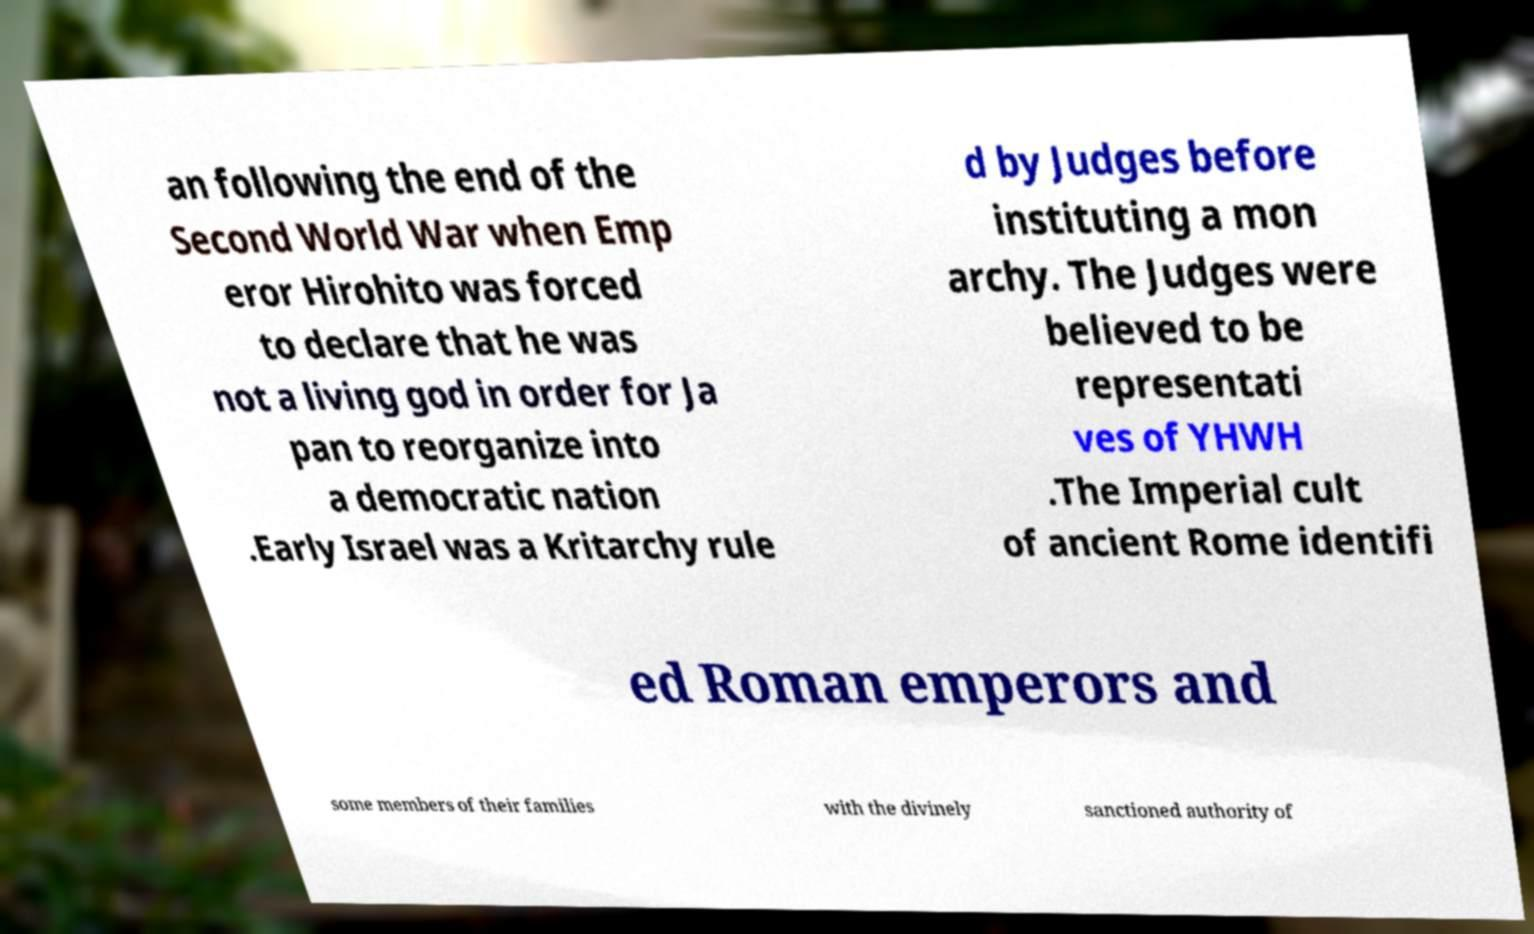I need the written content from this picture converted into text. Can you do that? an following the end of the Second World War when Emp eror Hirohito was forced to declare that he was not a living god in order for Ja pan to reorganize into a democratic nation .Early Israel was a Kritarchy rule d by Judges before instituting a mon archy. The Judges were believed to be representati ves of YHWH .The Imperial cult of ancient Rome identifi ed Roman emperors and some members of their families with the divinely sanctioned authority of 